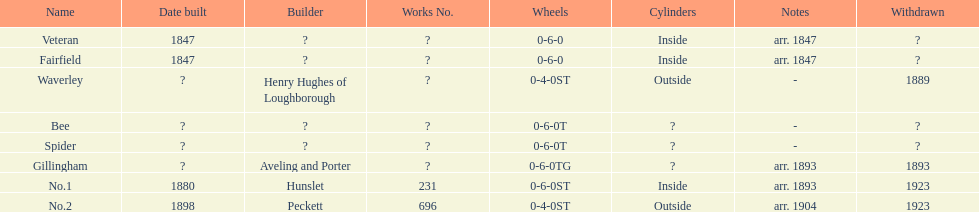In 1847, how many structures were constructed? 2. 